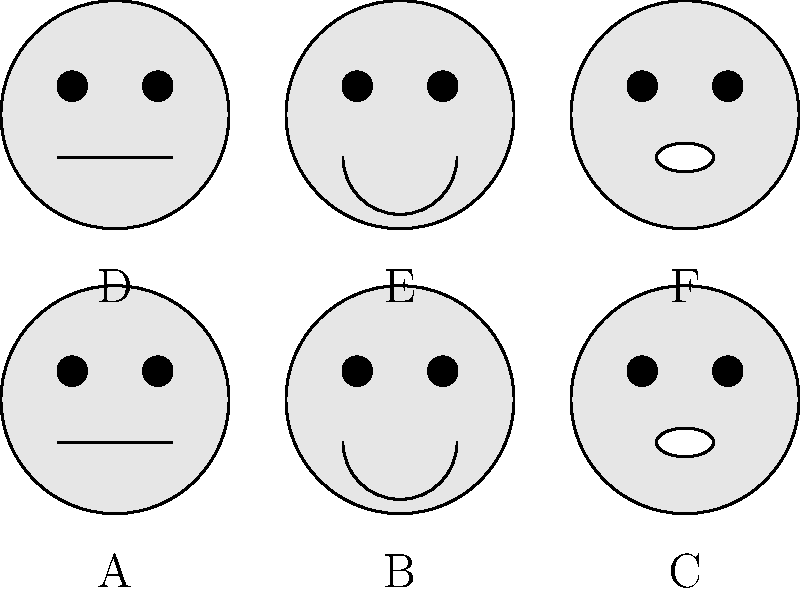As a film director working with Asian-American actors, you're reviewing headshots for a role that requires a range of emotions. Which image best represents a surprised expression, and how does it differ from the neutral expressions shown? To answer this question, we need to analyze the facial expressions in each headshot:

1. Images A and D show neutral expressions, characterized by:
   - Eyes open normally
   - Mouth in a straight line

2. Images B and E display happy expressions, identifiable by:
   - Eyes potentially slightly narrowed
   - Upturned mouth forming a smile

3. Images C and F exhibit surprised expressions, distinguished by:
   - Eyes wide open
   - Mouth open in an 'O' shape

The surprised expression is best represented by images C and F. These differ from the neutral expressions (A and D) in the following ways:

a) Eyes: In the surprised expression, the eyes are wider open, indicating shock or amazement. In contrast, the neutral expression shows eyes at a normal, relaxed state.

b) Mouth: The surprised expression features an open mouth in an 'O' shape, suggesting a gasp or exclamation. The neutral expression, however, shows a closed mouth in a straight line.

c) Overall facial tension: While not explicitly shown in simple drawings, a surprised expression typically involves more facial muscle tension, particularly around the eyes and forehead, compared to a relaxed, neutral expression.

Given these observations, the images that best represent a surprised expression are C and F.
Answer: C and F (surprised); wider eyes and open mouth versus neutral's normal eyes and closed mouth. 